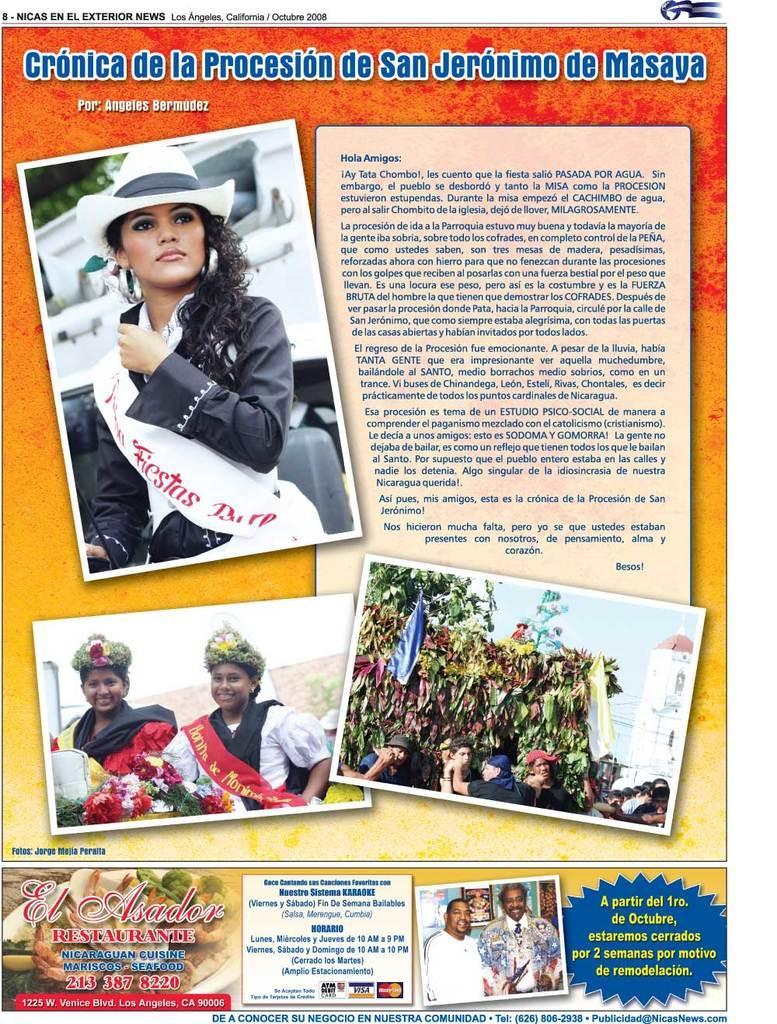Could you give a brief overview of what you see in this image? In this picture I can see photos. In the photos I can see women who are wearing clothes and some other objects. I can also see people, a building, trees and some other objects. Here I can see some text written on the image. 